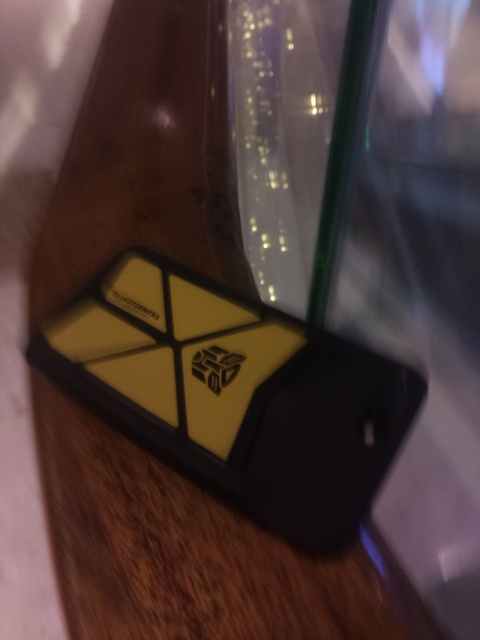Can you describe the item in the image? It appears to be a mobile phone case lying on a flat surface. The case displays a striking logo, reminiscent of a popular symbol from a sci-fi franchise. 